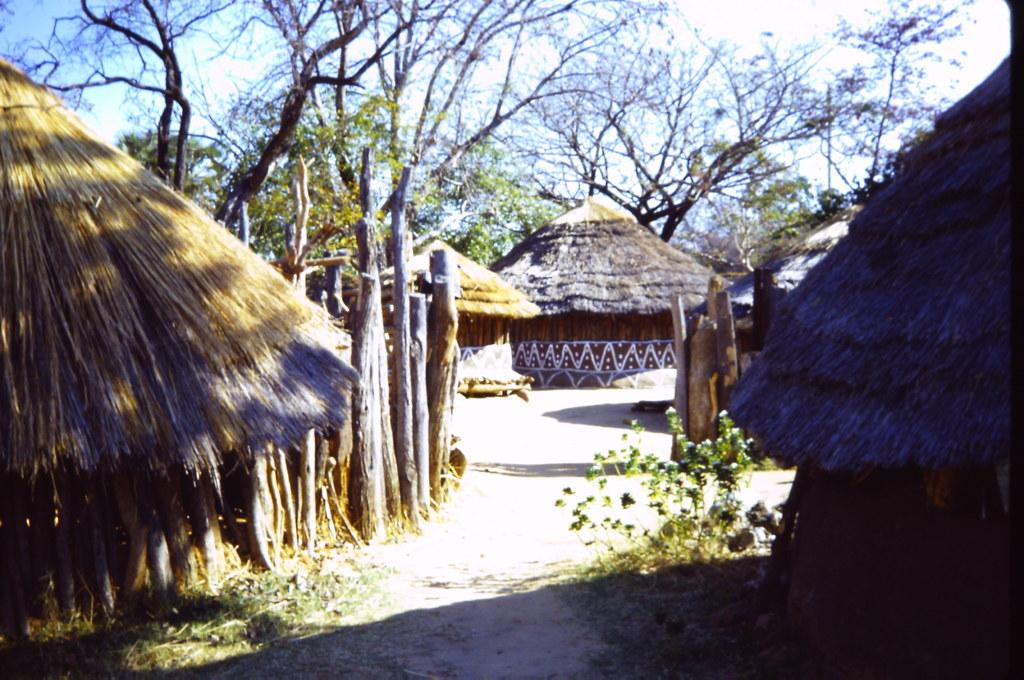What type of settlement is shown in the image? The image depicts a village. What kind of structures can be seen in the village? There are huts in the village. What natural elements are present in the image? There are trees, grass, and plants in the image. What part of the natural environment is visible at the top of the image? The sky is visible at the top of the image. Can you tell me where the blood is coming from in the image? There is no blood present in the image; it features a village with huts, trees, grass, and plants. What type of shop can be seen in the image? There is no shop present in the image; it depicts a village with huts, trees, grass, and plants. 